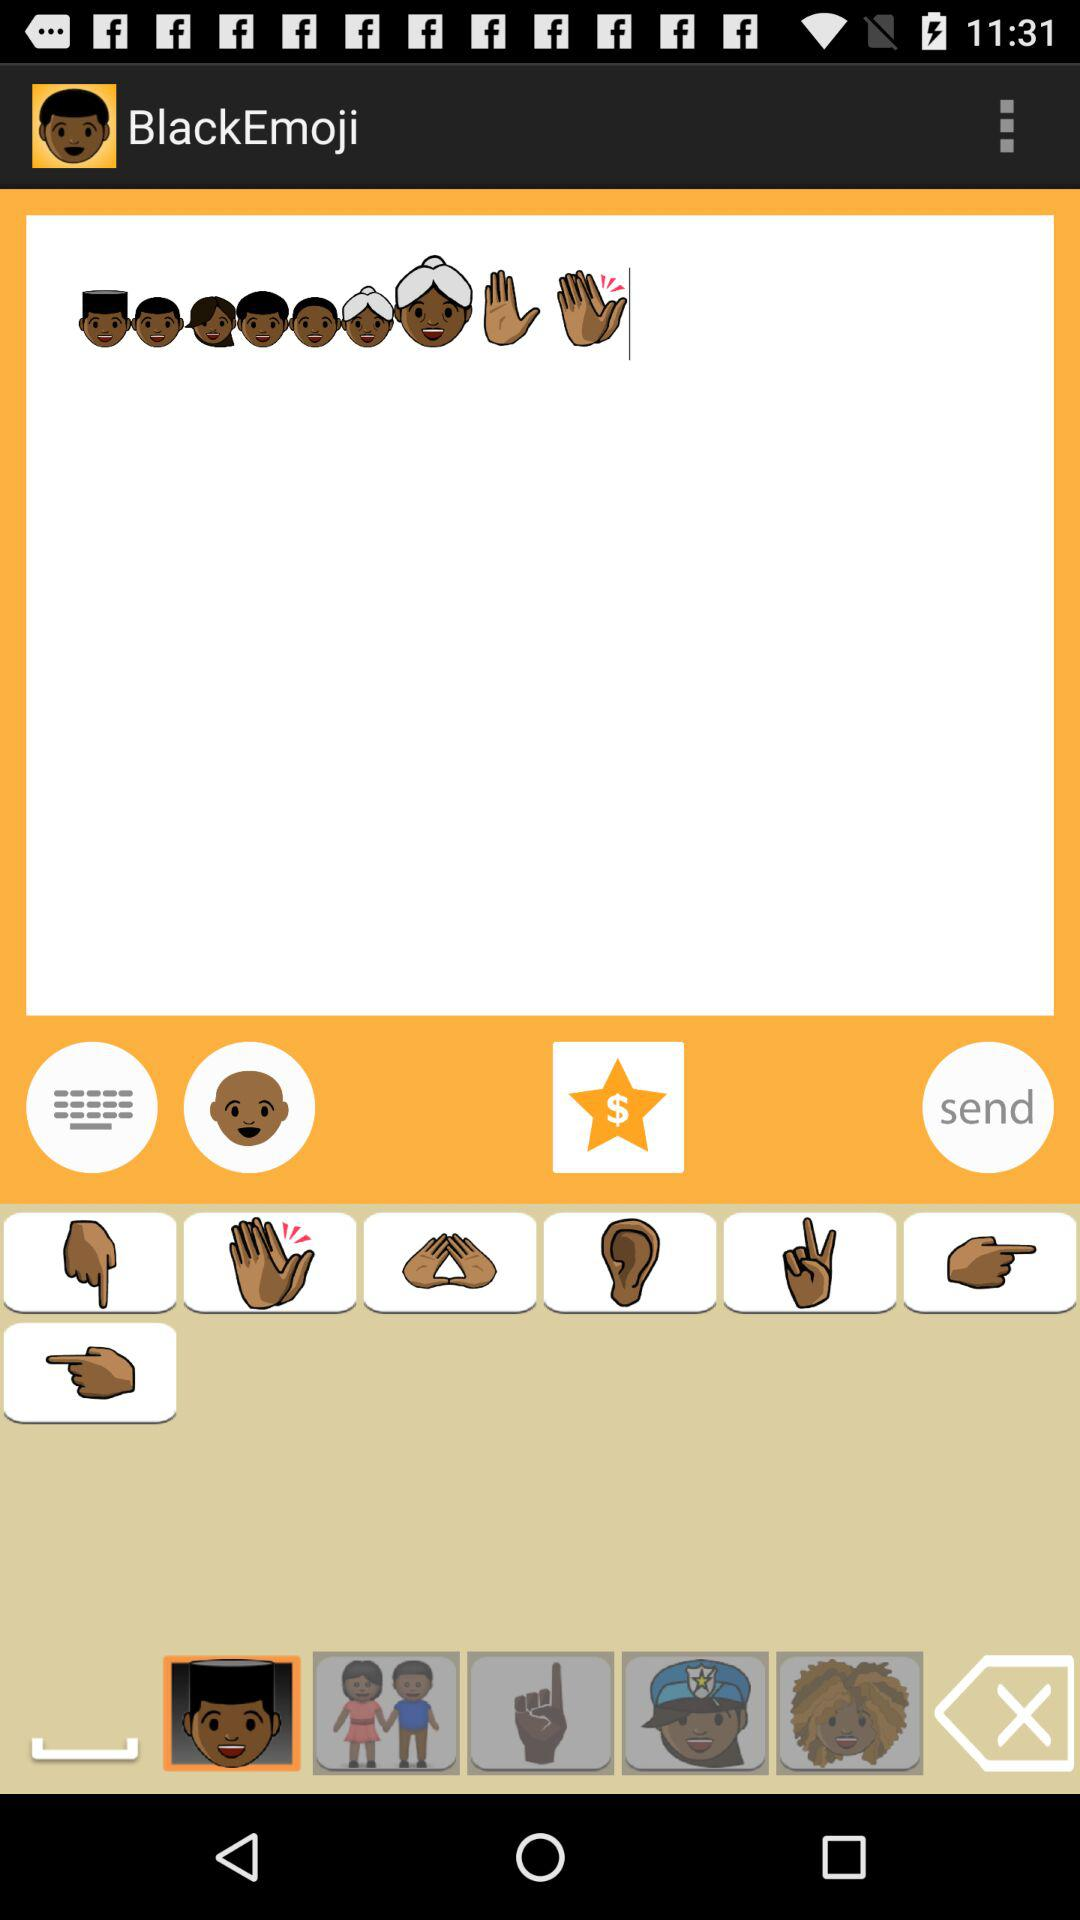What is the app name? The app name is "BlackEmoji". 